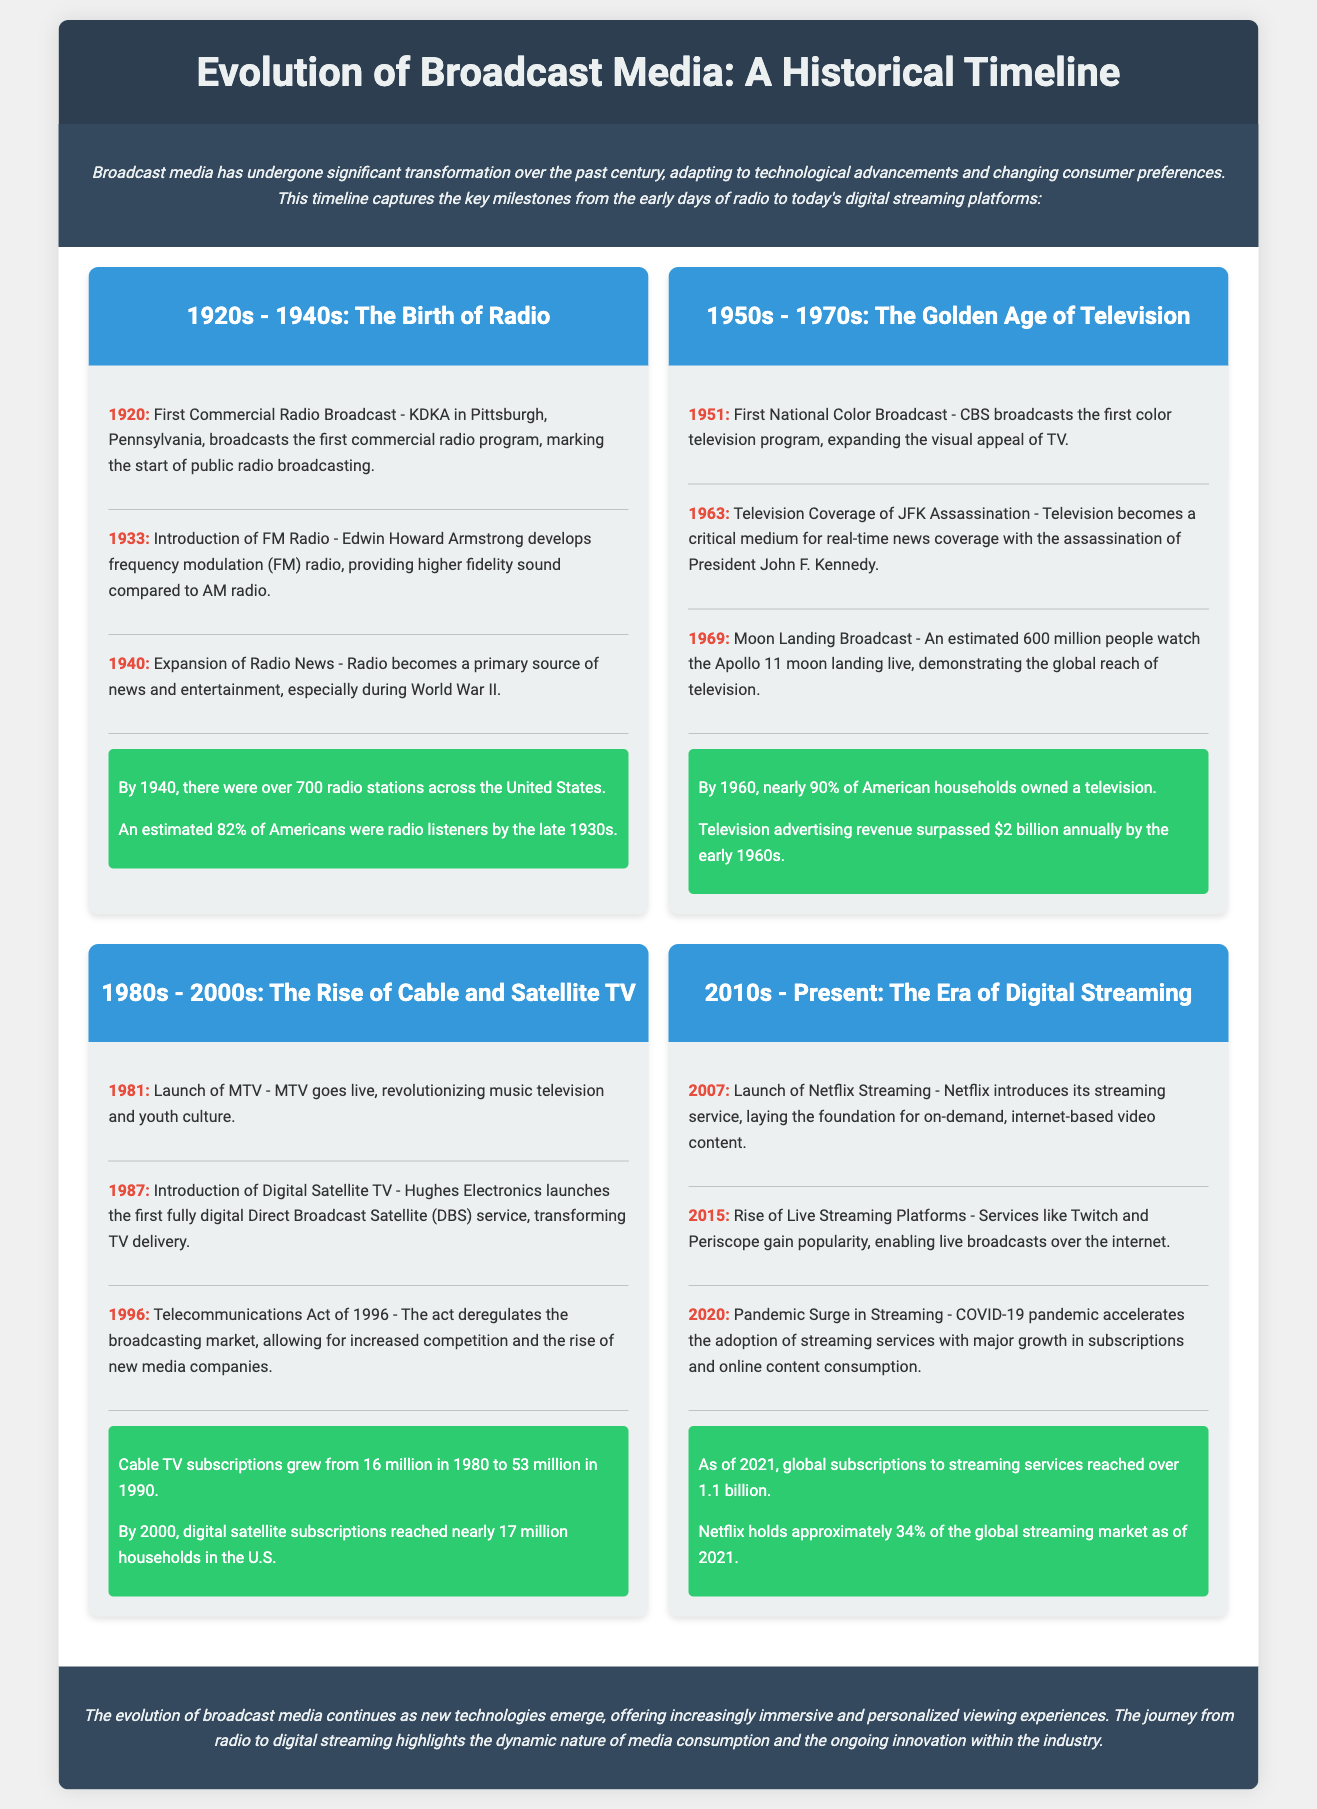what year did the first commercial radio broadcast occur? The document states that the first commercial radio broadcast took place in 1920.
Answer: 1920 what technology was developed in 1933? The document mentions that FM radio was introduced in 1933, developed by Edwin Howard Armstrong.
Answer: FM Radio how many radio stations were there in the U.S. by 1940? According to the statistics in the document, there were over 700 radio stations in the U.S. by 1940.
Answer: over 700 what significant event was televised in 1963? The document notes that the assassination of President John F. Kennedy was televised in 1963.
Answer: JFK Assassination what percentage of American households owned a television by 1960? The document indicates that nearly 90% of American households owned a television by 1960.
Answer: 90% which platform did Netflix launch in 2007? The document states that Netflix launched its streaming service in 2007.
Answer: Streaming Service what act in 1996 influenced the broadcasting market? The document refers to the Telecommunications Act of 1996 as the act that influenced the broadcasting market.
Answer: Telecommunications Act by 2021, approximately what percentage of the global streaming market did Netflix hold? The document states that Netflix held approximately 34% of the global streaming market as of 2021.
Answer: 34% 